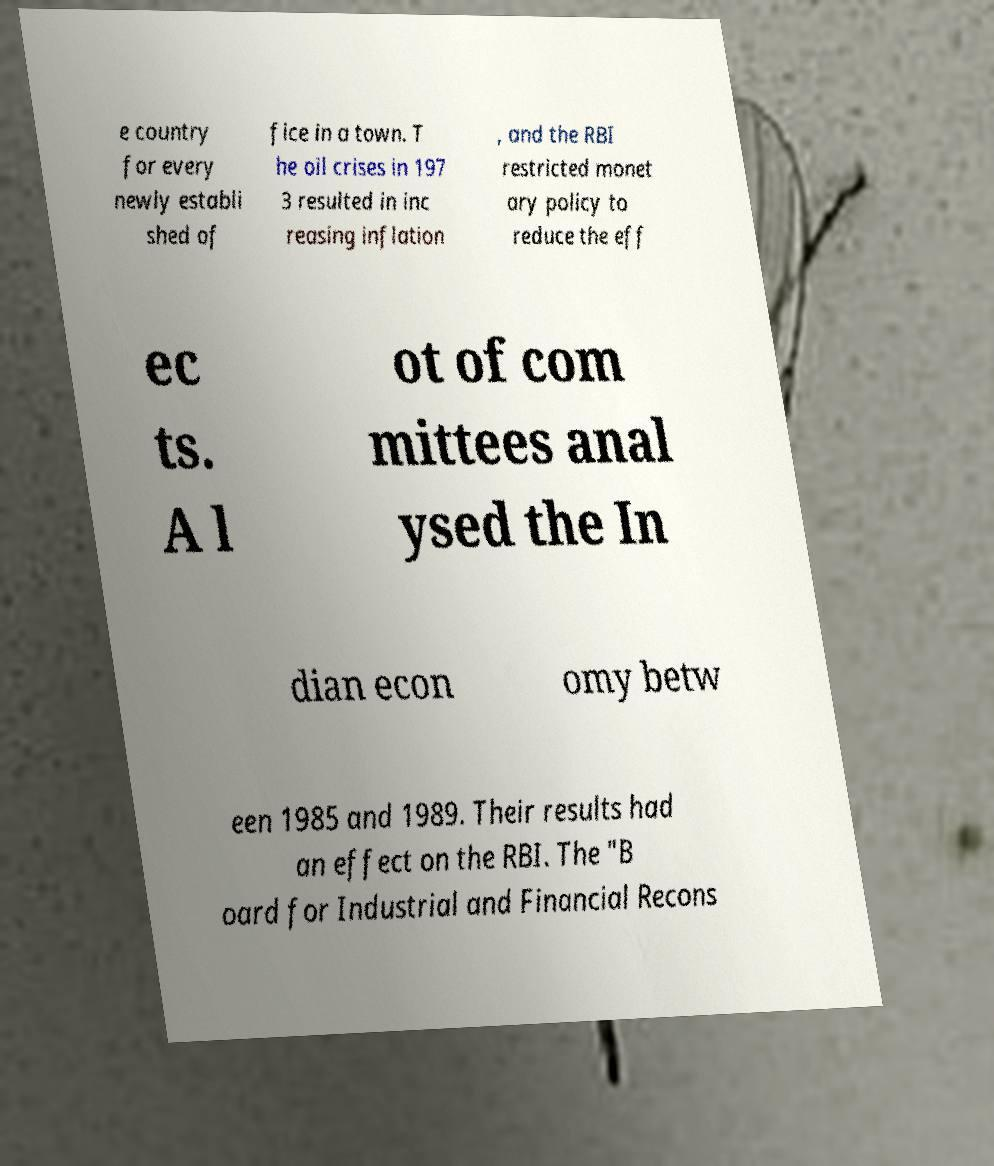I need the written content from this picture converted into text. Can you do that? e country for every newly establi shed of fice in a town. T he oil crises in 197 3 resulted in inc reasing inflation , and the RBI restricted monet ary policy to reduce the eff ec ts. A l ot of com mittees anal ysed the In dian econ omy betw een 1985 and 1989. Their results had an effect on the RBI. The "B oard for Industrial and Financial Recons 